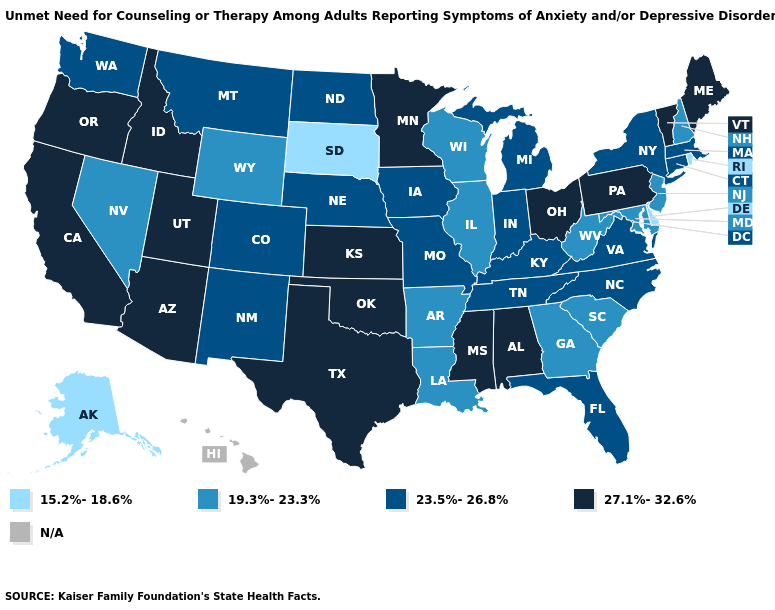Does the first symbol in the legend represent the smallest category?
Short answer required. Yes. How many symbols are there in the legend?
Give a very brief answer. 5. Does Oklahoma have the lowest value in the USA?
Answer briefly. No. Name the states that have a value in the range N/A?
Short answer required. Hawaii. Name the states that have a value in the range 23.5%-26.8%?
Concise answer only. Colorado, Connecticut, Florida, Indiana, Iowa, Kentucky, Massachusetts, Michigan, Missouri, Montana, Nebraska, New Mexico, New York, North Carolina, North Dakota, Tennessee, Virginia, Washington. Name the states that have a value in the range N/A?
Keep it brief. Hawaii. Name the states that have a value in the range 15.2%-18.6%?
Quick response, please. Alaska, Delaware, Rhode Island, South Dakota. What is the highest value in the MidWest ?
Answer briefly. 27.1%-32.6%. What is the value of Wisconsin?
Be succinct. 19.3%-23.3%. Does the first symbol in the legend represent the smallest category?
Short answer required. Yes. Does Alaska have the lowest value in the West?
Short answer required. Yes. What is the highest value in the West ?
Answer briefly. 27.1%-32.6%. What is the value of New Mexico?
Write a very short answer. 23.5%-26.8%. 